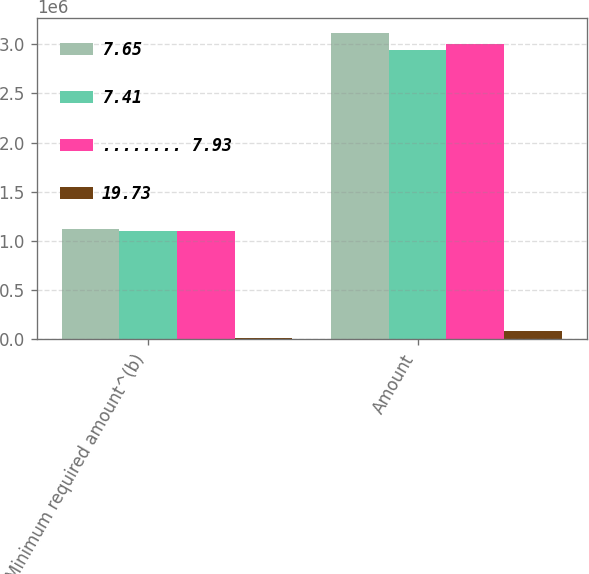Convert chart. <chart><loc_0><loc_0><loc_500><loc_500><stacked_bar_chart><ecel><fcel>Minimum required amount^(b)<fcel>Amount<nl><fcel>7.65<fcel>1.12108e+06<fcel>3.11408e+06<nl><fcel>7.41<fcel>1.10603e+06<fcel>2.93612e+06<nl><fcel>........ 7.93<fcel>1.10505e+06<fcel>2.99887e+06<nl><fcel>19.73<fcel>15948<fcel>82302<nl></chart> 